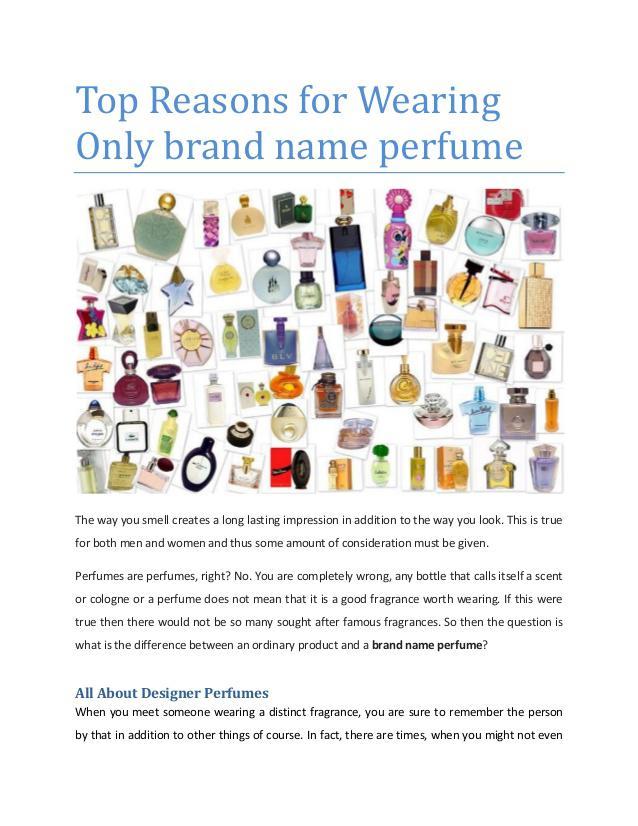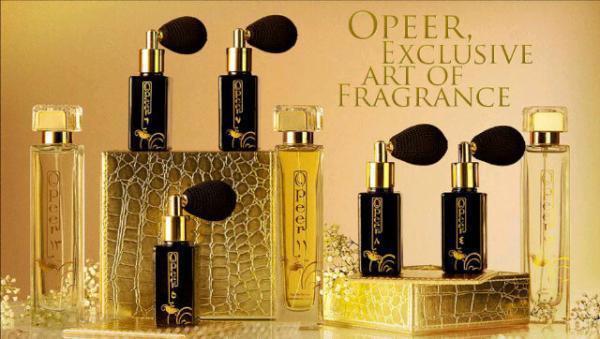The first image is the image on the left, the second image is the image on the right. Given the left and right images, does the statement "One of the images contains a single brand." hold true? Answer yes or no. Yes. 